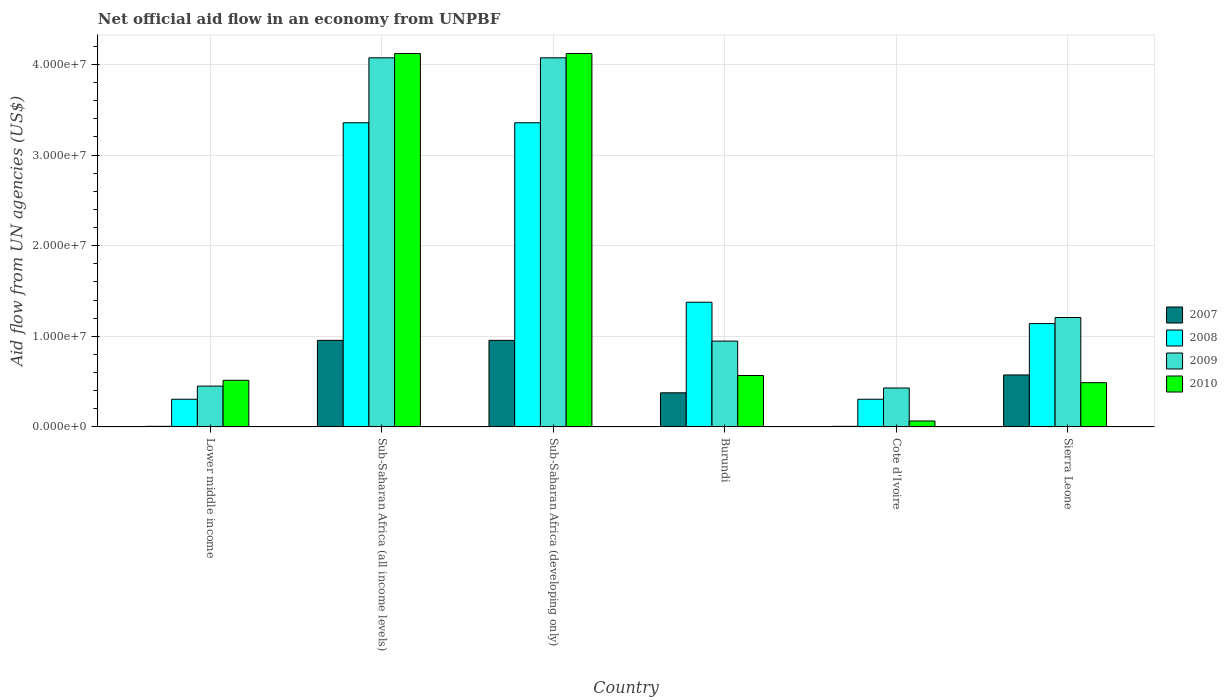Are the number of bars per tick equal to the number of legend labels?
Give a very brief answer. Yes. Are the number of bars on each tick of the X-axis equal?
Your answer should be compact. Yes. How many bars are there on the 3rd tick from the left?
Offer a very short reply. 4. What is the label of the 2nd group of bars from the left?
Give a very brief answer. Sub-Saharan Africa (all income levels). What is the net official aid flow in 2010 in Lower middle income?
Provide a short and direct response. 5.14e+06. Across all countries, what is the maximum net official aid flow in 2010?
Keep it short and to the point. 4.12e+07. Across all countries, what is the minimum net official aid flow in 2009?
Your response must be concise. 4.29e+06. In which country was the net official aid flow in 2009 maximum?
Make the answer very short. Sub-Saharan Africa (all income levels). In which country was the net official aid flow in 2007 minimum?
Keep it short and to the point. Lower middle income. What is the total net official aid flow in 2007 in the graph?
Offer a terse response. 2.87e+07. What is the difference between the net official aid flow in 2010 in Sub-Saharan Africa (all income levels) and that in Sub-Saharan Africa (developing only)?
Provide a succinct answer. 0. What is the difference between the net official aid flow in 2008 in Sierra Leone and the net official aid flow in 2010 in Sub-Saharan Africa (developing only)?
Make the answer very short. -2.98e+07. What is the average net official aid flow in 2009 per country?
Offer a very short reply. 1.86e+07. What is the difference between the net official aid flow of/in 2010 and net official aid flow of/in 2007 in Lower middle income?
Your answer should be very brief. 5.08e+06. What is the ratio of the net official aid flow in 2010 in Burundi to that in Cote d'Ivoire?
Give a very brief answer. 8.72. Is the net official aid flow in 2009 in Lower middle income less than that in Sierra Leone?
Make the answer very short. Yes. What is the difference between the highest and the second highest net official aid flow in 2008?
Provide a succinct answer. 1.98e+07. What is the difference between the highest and the lowest net official aid flow in 2009?
Your response must be concise. 3.64e+07. In how many countries, is the net official aid flow in 2010 greater than the average net official aid flow in 2010 taken over all countries?
Give a very brief answer. 2. Is the sum of the net official aid flow in 2010 in Burundi and Sub-Saharan Africa (developing only) greater than the maximum net official aid flow in 2007 across all countries?
Provide a short and direct response. Yes. Is it the case that in every country, the sum of the net official aid flow in 2008 and net official aid flow in 2010 is greater than the sum of net official aid flow in 2007 and net official aid flow in 2009?
Ensure brevity in your answer.  No. What does the 4th bar from the right in Sierra Leone represents?
Keep it short and to the point. 2007. Is it the case that in every country, the sum of the net official aid flow in 2008 and net official aid flow in 2007 is greater than the net official aid flow in 2010?
Offer a very short reply. No. Are all the bars in the graph horizontal?
Your answer should be compact. No. What is the difference between two consecutive major ticks on the Y-axis?
Make the answer very short. 1.00e+07. Are the values on the major ticks of Y-axis written in scientific E-notation?
Provide a short and direct response. Yes. Does the graph contain any zero values?
Keep it short and to the point. No. Does the graph contain grids?
Your answer should be compact. Yes. How are the legend labels stacked?
Provide a succinct answer. Vertical. What is the title of the graph?
Your answer should be very brief. Net official aid flow in an economy from UNPBF. Does "1999" appear as one of the legend labels in the graph?
Provide a short and direct response. No. What is the label or title of the Y-axis?
Your answer should be very brief. Aid flow from UN agencies (US$). What is the Aid flow from UN agencies (US$) in 2007 in Lower middle income?
Your answer should be compact. 6.00e+04. What is the Aid flow from UN agencies (US$) in 2008 in Lower middle income?
Provide a short and direct response. 3.05e+06. What is the Aid flow from UN agencies (US$) in 2009 in Lower middle income?
Provide a short and direct response. 4.50e+06. What is the Aid flow from UN agencies (US$) in 2010 in Lower middle income?
Your response must be concise. 5.14e+06. What is the Aid flow from UN agencies (US$) of 2007 in Sub-Saharan Africa (all income levels)?
Ensure brevity in your answer.  9.55e+06. What is the Aid flow from UN agencies (US$) of 2008 in Sub-Saharan Africa (all income levels)?
Make the answer very short. 3.36e+07. What is the Aid flow from UN agencies (US$) of 2009 in Sub-Saharan Africa (all income levels)?
Ensure brevity in your answer.  4.07e+07. What is the Aid flow from UN agencies (US$) in 2010 in Sub-Saharan Africa (all income levels)?
Keep it short and to the point. 4.12e+07. What is the Aid flow from UN agencies (US$) of 2007 in Sub-Saharan Africa (developing only)?
Ensure brevity in your answer.  9.55e+06. What is the Aid flow from UN agencies (US$) of 2008 in Sub-Saharan Africa (developing only)?
Your answer should be very brief. 3.36e+07. What is the Aid flow from UN agencies (US$) of 2009 in Sub-Saharan Africa (developing only)?
Your answer should be compact. 4.07e+07. What is the Aid flow from UN agencies (US$) of 2010 in Sub-Saharan Africa (developing only)?
Your response must be concise. 4.12e+07. What is the Aid flow from UN agencies (US$) in 2007 in Burundi?
Make the answer very short. 3.76e+06. What is the Aid flow from UN agencies (US$) in 2008 in Burundi?
Provide a short and direct response. 1.38e+07. What is the Aid flow from UN agencies (US$) of 2009 in Burundi?
Offer a terse response. 9.47e+06. What is the Aid flow from UN agencies (US$) of 2010 in Burundi?
Offer a very short reply. 5.67e+06. What is the Aid flow from UN agencies (US$) in 2008 in Cote d'Ivoire?
Make the answer very short. 3.05e+06. What is the Aid flow from UN agencies (US$) in 2009 in Cote d'Ivoire?
Provide a succinct answer. 4.29e+06. What is the Aid flow from UN agencies (US$) in 2010 in Cote d'Ivoire?
Offer a terse response. 6.50e+05. What is the Aid flow from UN agencies (US$) of 2007 in Sierra Leone?
Ensure brevity in your answer.  5.73e+06. What is the Aid flow from UN agencies (US$) in 2008 in Sierra Leone?
Give a very brief answer. 1.14e+07. What is the Aid flow from UN agencies (US$) in 2009 in Sierra Leone?
Give a very brief answer. 1.21e+07. What is the Aid flow from UN agencies (US$) in 2010 in Sierra Leone?
Ensure brevity in your answer.  4.88e+06. Across all countries, what is the maximum Aid flow from UN agencies (US$) of 2007?
Keep it short and to the point. 9.55e+06. Across all countries, what is the maximum Aid flow from UN agencies (US$) in 2008?
Ensure brevity in your answer.  3.36e+07. Across all countries, what is the maximum Aid flow from UN agencies (US$) of 2009?
Provide a short and direct response. 4.07e+07. Across all countries, what is the maximum Aid flow from UN agencies (US$) in 2010?
Provide a short and direct response. 4.12e+07. Across all countries, what is the minimum Aid flow from UN agencies (US$) of 2008?
Provide a short and direct response. 3.05e+06. Across all countries, what is the minimum Aid flow from UN agencies (US$) in 2009?
Provide a succinct answer. 4.29e+06. Across all countries, what is the minimum Aid flow from UN agencies (US$) of 2010?
Make the answer very short. 6.50e+05. What is the total Aid flow from UN agencies (US$) of 2007 in the graph?
Give a very brief answer. 2.87e+07. What is the total Aid flow from UN agencies (US$) of 2008 in the graph?
Offer a terse response. 9.84e+07. What is the total Aid flow from UN agencies (US$) of 2009 in the graph?
Make the answer very short. 1.12e+08. What is the total Aid flow from UN agencies (US$) of 2010 in the graph?
Offer a very short reply. 9.88e+07. What is the difference between the Aid flow from UN agencies (US$) of 2007 in Lower middle income and that in Sub-Saharan Africa (all income levels)?
Provide a succinct answer. -9.49e+06. What is the difference between the Aid flow from UN agencies (US$) of 2008 in Lower middle income and that in Sub-Saharan Africa (all income levels)?
Offer a very short reply. -3.05e+07. What is the difference between the Aid flow from UN agencies (US$) of 2009 in Lower middle income and that in Sub-Saharan Africa (all income levels)?
Provide a short and direct response. -3.62e+07. What is the difference between the Aid flow from UN agencies (US$) in 2010 in Lower middle income and that in Sub-Saharan Africa (all income levels)?
Offer a terse response. -3.61e+07. What is the difference between the Aid flow from UN agencies (US$) in 2007 in Lower middle income and that in Sub-Saharan Africa (developing only)?
Offer a terse response. -9.49e+06. What is the difference between the Aid flow from UN agencies (US$) of 2008 in Lower middle income and that in Sub-Saharan Africa (developing only)?
Your answer should be compact. -3.05e+07. What is the difference between the Aid flow from UN agencies (US$) of 2009 in Lower middle income and that in Sub-Saharan Africa (developing only)?
Make the answer very short. -3.62e+07. What is the difference between the Aid flow from UN agencies (US$) in 2010 in Lower middle income and that in Sub-Saharan Africa (developing only)?
Your answer should be very brief. -3.61e+07. What is the difference between the Aid flow from UN agencies (US$) in 2007 in Lower middle income and that in Burundi?
Provide a succinct answer. -3.70e+06. What is the difference between the Aid flow from UN agencies (US$) of 2008 in Lower middle income and that in Burundi?
Make the answer very short. -1.07e+07. What is the difference between the Aid flow from UN agencies (US$) in 2009 in Lower middle income and that in Burundi?
Offer a very short reply. -4.97e+06. What is the difference between the Aid flow from UN agencies (US$) of 2010 in Lower middle income and that in Burundi?
Provide a succinct answer. -5.30e+05. What is the difference between the Aid flow from UN agencies (US$) of 2009 in Lower middle income and that in Cote d'Ivoire?
Make the answer very short. 2.10e+05. What is the difference between the Aid flow from UN agencies (US$) in 2010 in Lower middle income and that in Cote d'Ivoire?
Your answer should be compact. 4.49e+06. What is the difference between the Aid flow from UN agencies (US$) of 2007 in Lower middle income and that in Sierra Leone?
Ensure brevity in your answer.  -5.67e+06. What is the difference between the Aid flow from UN agencies (US$) of 2008 in Lower middle income and that in Sierra Leone?
Offer a very short reply. -8.35e+06. What is the difference between the Aid flow from UN agencies (US$) of 2009 in Lower middle income and that in Sierra Leone?
Keep it short and to the point. -7.57e+06. What is the difference between the Aid flow from UN agencies (US$) in 2010 in Lower middle income and that in Sierra Leone?
Your response must be concise. 2.60e+05. What is the difference between the Aid flow from UN agencies (US$) in 2008 in Sub-Saharan Africa (all income levels) and that in Sub-Saharan Africa (developing only)?
Make the answer very short. 0. What is the difference between the Aid flow from UN agencies (US$) of 2010 in Sub-Saharan Africa (all income levels) and that in Sub-Saharan Africa (developing only)?
Your answer should be very brief. 0. What is the difference between the Aid flow from UN agencies (US$) of 2007 in Sub-Saharan Africa (all income levels) and that in Burundi?
Offer a very short reply. 5.79e+06. What is the difference between the Aid flow from UN agencies (US$) of 2008 in Sub-Saharan Africa (all income levels) and that in Burundi?
Your response must be concise. 1.98e+07. What is the difference between the Aid flow from UN agencies (US$) of 2009 in Sub-Saharan Africa (all income levels) and that in Burundi?
Keep it short and to the point. 3.13e+07. What is the difference between the Aid flow from UN agencies (US$) in 2010 in Sub-Saharan Africa (all income levels) and that in Burundi?
Provide a succinct answer. 3.55e+07. What is the difference between the Aid flow from UN agencies (US$) in 2007 in Sub-Saharan Africa (all income levels) and that in Cote d'Ivoire?
Provide a succinct answer. 9.49e+06. What is the difference between the Aid flow from UN agencies (US$) in 2008 in Sub-Saharan Africa (all income levels) and that in Cote d'Ivoire?
Give a very brief answer. 3.05e+07. What is the difference between the Aid flow from UN agencies (US$) in 2009 in Sub-Saharan Africa (all income levels) and that in Cote d'Ivoire?
Ensure brevity in your answer.  3.64e+07. What is the difference between the Aid flow from UN agencies (US$) in 2010 in Sub-Saharan Africa (all income levels) and that in Cote d'Ivoire?
Make the answer very short. 4.06e+07. What is the difference between the Aid flow from UN agencies (US$) in 2007 in Sub-Saharan Africa (all income levels) and that in Sierra Leone?
Offer a terse response. 3.82e+06. What is the difference between the Aid flow from UN agencies (US$) in 2008 in Sub-Saharan Africa (all income levels) and that in Sierra Leone?
Keep it short and to the point. 2.22e+07. What is the difference between the Aid flow from UN agencies (US$) of 2009 in Sub-Saharan Africa (all income levels) and that in Sierra Leone?
Make the answer very short. 2.87e+07. What is the difference between the Aid flow from UN agencies (US$) in 2010 in Sub-Saharan Africa (all income levels) and that in Sierra Leone?
Keep it short and to the point. 3.63e+07. What is the difference between the Aid flow from UN agencies (US$) in 2007 in Sub-Saharan Africa (developing only) and that in Burundi?
Provide a short and direct response. 5.79e+06. What is the difference between the Aid flow from UN agencies (US$) in 2008 in Sub-Saharan Africa (developing only) and that in Burundi?
Offer a terse response. 1.98e+07. What is the difference between the Aid flow from UN agencies (US$) in 2009 in Sub-Saharan Africa (developing only) and that in Burundi?
Keep it short and to the point. 3.13e+07. What is the difference between the Aid flow from UN agencies (US$) in 2010 in Sub-Saharan Africa (developing only) and that in Burundi?
Keep it short and to the point. 3.55e+07. What is the difference between the Aid flow from UN agencies (US$) of 2007 in Sub-Saharan Africa (developing only) and that in Cote d'Ivoire?
Provide a short and direct response. 9.49e+06. What is the difference between the Aid flow from UN agencies (US$) in 2008 in Sub-Saharan Africa (developing only) and that in Cote d'Ivoire?
Provide a succinct answer. 3.05e+07. What is the difference between the Aid flow from UN agencies (US$) of 2009 in Sub-Saharan Africa (developing only) and that in Cote d'Ivoire?
Keep it short and to the point. 3.64e+07. What is the difference between the Aid flow from UN agencies (US$) of 2010 in Sub-Saharan Africa (developing only) and that in Cote d'Ivoire?
Your answer should be very brief. 4.06e+07. What is the difference between the Aid flow from UN agencies (US$) in 2007 in Sub-Saharan Africa (developing only) and that in Sierra Leone?
Provide a short and direct response. 3.82e+06. What is the difference between the Aid flow from UN agencies (US$) in 2008 in Sub-Saharan Africa (developing only) and that in Sierra Leone?
Offer a terse response. 2.22e+07. What is the difference between the Aid flow from UN agencies (US$) of 2009 in Sub-Saharan Africa (developing only) and that in Sierra Leone?
Give a very brief answer. 2.87e+07. What is the difference between the Aid flow from UN agencies (US$) of 2010 in Sub-Saharan Africa (developing only) and that in Sierra Leone?
Make the answer very short. 3.63e+07. What is the difference between the Aid flow from UN agencies (US$) of 2007 in Burundi and that in Cote d'Ivoire?
Keep it short and to the point. 3.70e+06. What is the difference between the Aid flow from UN agencies (US$) of 2008 in Burundi and that in Cote d'Ivoire?
Your response must be concise. 1.07e+07. What is the difference between the Aid flow from UN agencies (US$) of 2009 in Burundi and that in Cote d'Ivoire?
Ensure brevity in your answer.  5.18e+06. What is the difference between the Aid flow from UN agencies (US$) in 2010 in Burundi and that in Cote d'Ivoire?
Make the answer very short. 5.02e+06. What is the difference between the Aid flow from UN agencies (US$) in 2007 in Burundi and that in Sierra Leone?
Provide a succinct answer. -1.97e+06. What is the difference between the Aid flow from UN agencies (US$) of 2008 in Burundi and that in Sierra Leone?
Make the answer very short. 2.36e+06. What is the difference between the Aid flow from UN agencies (US$) in 2009 in Burundi and that in Sierra Leone?
Provide a succinct answer. -2.60e+06. What is the difference between the Aid flow from UN agencies (US$) in 2010 in Burundi and that in Sierra Leone?
Your answer should be compact. 7.90e+05. What is the difference between the Aid flow from UN agencies (US$) of 2007 in Cote d'Ivoire and that in Sierra Leone?
Your answer should be compact. -5.67e+06. What is the difference between the Aid flow from UN agencies (US$) of 2008 in Cote d'Ivoire and that in Sierra Leone?
Give a very brief answer. -8.35e+06. What is the difference between the Aid flow from UN agencies (US$) of 2009 in Cote d'Ivoire and that in Sierra Leone?
Your answer should be compact. -7.78e+06. What is the difference between the Aid flow from UN agencies (US$) in 2010 in Cote d'Ivoire and that in Sierra Leone?
Provide a succinct answer. -4.23e+06. What is the difference between the Aid flow from UN agencies (US$) in 2007 in Lower middle income and the Aid flow from UN agencies (US$) in 2008 in Sub-Saharan Africa (all income levels)?
Give a very brief answer. -3.35e+07. What is the difference between the Aid flow from UN agencies (US$) of 2007 in Lower middle income and the Aid flow from UN agencies (US$) of 2009 in Sub-Saharan Africa (all income levels)?
Make the answer very short. -4.07e+07. What is the difference between the Aid flow from UN agencies (US$) in 2007 in Lower middle income and the Aid flow from UN agencies (US$) in 2010 in Sub-Saharan Africa (all income levels)?
Provide a succinct answer. -4.12e+07. What is the difference between the Aid flow from UN agencies (US$) of 2008 in Lower middle income and the Aid flow from UN agencies (US$) of 2009 in Sub-Saharan Africa (all income levels)?
Give a very brief answer. -3.77e+07. What is the difference between the Aid flow from UN agencies (US$) of 2008 in Lower middle income and the Aid flow from UN agencies (US$) of 2010 in Sub-Saharan Africa (all income levels)?
Ensure brevity in your answer.  -3.82e+07. What is the difference between the Aid flow from UN agencies (US$) of 2009 in Lower middle income and the Aid flow from UN agencies (US$) of 2010 in Sub-Saharan Africa (all income levels)?
Give a very brief answer. -3.67e+07. What is the difference between the Aid flow from UN agencies (US$) of 2007 in Lower middle income and the Aid flow from UN agencies (US$) of 2008 in Sub-Saharan Africa (developing only)?
Make the answer very short. -3.35e+07. What is the difference between the Aid flow from UN agencies (US$) of 2007 in Lower middle income and the Aid flow from UN agencies (US$) of 2009 in Sub-Saharan Africa (developing only)?
Offer a very short reply. -4.07e+07. What is the difference between the Aid flow from UN agencies (US$) of 2007 in Lower middle income and the Aid flow from UN agencies (US$) of 2010 in Sub-Saharan Africa (developing only)?
Your answer should be compact. -4.12e+07. What is the difference between the Aid flow from UN agencies (US$) in 2008 in Lower middle income and the Aid flow from UN agencies (US$) in 2009 in Sub-Saharan Africa (developing only)?
Ensure brevity in your answer.  -3.77e+07. What is the difference between the Aid flow from UN agencies (US$) of 2008 in Lower middle income and the Aid flow from UN agencies (US$) of 2010 in Sub-Saharan Africa (developing only)?
Your answer should be very brief. -3.82e+07. What is the difference between the Aid flow from UN agencies (US$) of 2009 in Lower middle income and the Aid flow from UN agencies (US$) of 2010 in Sub-Saharan Africa (developing only)?
Your answer should be very brief. -3.67e+07. What is the difference between the Aid flow from UN agencies (US$) of 2007 in Lower middle income and the Aid flow from UN agencies (US$) of 2008 in Burundi?
Offer a very short reply. -1.37e+07. What is the difference between the Aid flow from UN agencies (US$) in 2007 in Lower middle income and the Aid flow from UN agencies (US$) in 2009 in Burundi?
Give a very brief answer. -9.41e+06. What is the difference between the Aid flow from UN agencies (US$) of 2007 in Lower middle income and the Aid flow from UN agencies (US$) of 2010 in Burundi?
Offer a terse response. -5.61e+06. What is the difference between the Aid flow from UN agencies (US$) of 2008 in Lower middle income and the Aid flow from UN agencies (US$) of 2009 in Burundi?
Make the answer very short. -6.42e+06. What is the difference between the Aid flow from UN agencies (US$) of 2008 in Lower middle income and the Aid flow from UN agencies (US$) of 2010 in Burundi?
Give a very brief answer. -2.62e+06. What is the difference between the Aid flow from UN agencies (US$) of 2009 in Lower middle income and the Aid flow from UN agencies (US$) of 2010 in Burundi?
Your answer should be compact. -1.17e+06. What is the difference between the Aid flow from UN agencies (US$) in 2007 in Lower middle income and the Aid flow from UN agencies (US$) in 2008 in Cote d'Ivoire?
Provide a succinct answer. -2.99e+06. What is the difference between the Aid flow from UN agencies (US$) of 2007 in Lower middle income and the Aid flow from UN agencies (US$) of 2009 in Cote d'Ivoire?
Make the answer very short. -4.23e+06. What is the difference between the Aid flow from UN agencies (US$) in 2007 in Lower middle income and the Aid flow from UN agencies (US$) in 2010 in Cote d'Ivoire?
Provide a short and direct response. -5.90e+05. What is the difference between the Aid flow from UN agencies (US$) of 2008 in Lower middle income and the Aid flow from UN agencies (US$) of 2009 in Cote d'Ivoire?
Make the answer very short. -1.24e+06. What is the difference between the Aid flow from UN agencies (US$) in 2008 in Lower middle income and the Aid flow from UN agencies (US$) in 2010 in Cote d'Ivoire?
Keep it short and to the point. 2.40e+06. What is the difference between the Aid flow from UN agencies (US$) of 2009 in Lower middle income and the Aid flow from UN agencies (US$) of 2010 in Cote d'Ivoire?
Make the answer very short. 3.85e+06. What is the difference between the Aid flow from UN agencies (US$) in 2007 in Lower middle income and the Aid flow from UN agencies (US$) in 2008 in Sierra Leone?
Your response must be concise. -1.13e+07. What is the difference between the Aid flow from UN agencies (US$) in 2007 in Lower middle income and the Aid flow from UN agencies (US$) in 2009 in Sierra Leone?
Your answer should be compact. -1.20e+07. What is the difference between the Aid flow from UN agencies (US$) in 2007 in Lower middle income and the Aid flow from UN agencies (US$) in 2010 in Sierra Leone?
Give a very brief answer. -4.82e+06. What is the difference between the Aid flow from UN agencies (US$) of 2008 in Lower middle income and the Aid flow from UN agencies (US$) of 2009 in Sierra Leone?
Provide a succinct answer. -9.02e+06. What is the difference between the Aid flow from UN agencies (US$) of 2008 in Lower middle income and the Aid flow from UN agencies (US$) of 2010 in Sierra Leone?
Give a very brief answer. -1.83e+06. What is the difference between the Aid flow from UN agencies (US$) of 2009 in Lower middle income and the Aid flow from UN agencies (US$) of 2010 in Sierra Leone?
Ensure brevity in your answer.  -3.80e+05. What is the difference between the Aid flow from UN agencies (US$) of 2007 in Sub-Saharan Africa (all income levels) and the Aid flow from UN agencies (US$) of 2008 in Sub-Saharan Africa (developing only)?
Make the answer very short. -2.40e+07. What is the difference between the Aid flow from UN agencies (US$) in 2007 in Sub-Saharan Africa (all income levels) and the Aid flow from UN agencies (US$) in 2009 in Sub-Saharan Africa (developing only)?
Offer a terse response. -3.12e+07. What is the difference between the Aid flow from UN agencies (US$) in 2007 in Sub-Saharan Africa (all income levels) and the Aid flow from UN agencies (US$) in 2010 in Sub-Saharan Africa (developing only)?
Your answer should be compact. -3.17e+07. What is the difference between the Aid flow from UN agencies (US$) in 2008 in Sub-Saharan Africa (all income levels) and the Aid flow from UN agencies (US$) in 2009 in Sub-Saharan Africa (developing only)?
Provide a short and direct response. -7.17e+06. What is the difference between the Aid flow from UN agencies (US$) in 2008 in Sub-Saharan Africa (all income levels) and the Aid flow from UN agencies (US$) in 2010 in Sub-Saharan Africa (developing only)?
Offer a terse response. -7.64e+06. What is the difference between the Aid flow from UN agencies (US$) of 2009 in Sub-Saharan Africa (all income levels) and the Aid flow from UN agencies (US$) of 2010 in Sub-Saharan Africa (developing only)?
Offer a very short reply. -4.70e+05. What is the difference between the Aid flow from UN agencies (US$) in 2007 in Sub-Saharan Africa (all income levels) and the Aid flow from UN agencies (US$) in 2008 in Burundi?
Offer a terse response. -4.21e+06. What is the difference between the Aid flow from UN agencies (US$) of 2007 in Sub-Saharan Africa (all income levels) and the Aid flow from UN agencies (US$) of 2010 in Burundi?
Offer a very short reply. 3.88e+06. What is the difference between the Aid flow from UN agencies (US$) of 2008 in Sub-Saharan Africa (all income levels) and the Aid flow from UN agencies (US$) of 2009 in Burundi?
Keep it short and to the point. 2.41e+07. What is the difference between the Aid flow from UN agencies (US$) in 2008 in Sub-Saharan Africa (all income levels) and the Aid flow from UN agencies (US$) in 2010 in Burundi?
Your answer should be compact. 2.79e+07. What is the difference between the Aid flow from UN agencies (US$) in 2009 in Sub-Saharan Africa (all income levels) and the Aid flow from UN agencies (US$) in 2010 in Burundi?
Your answer should be compact. 3.51e+07. What is the difference between the Aid flow from UN agencies (US$) in 2007 in Sub-Saharan Africa (all income levels) and the Aid flow from UN agencies (US$) in 2008 in Cote d'Ivoire?
Your answer should be very brief. 6.50e+06. What is the difference between the Aid flow from UN agencies (US$) in 2007 in Sub-Saharan Africa (all income levels) and the Aid flow from UN agencies (US$) in 2009 in Cote d'Ivoire?
Your response must be concise. 5.26e+06. What is the difference between the Aid flow from UN agencies (US$) in 2007 in Sub-Saharan Africa (all income levels) and the Aid flow from UN agencies (US$) in 2010 in Cote d'Ivoire?
Give a very brief answer. 8.90e+06. What is the difference between the Aid flow from UN agencies (US$) in 2008 in Sub-Saharan Africa (all income levels) and the Aid flow from UN agencies (US$) in 2009 in Cote d'Ivoire?
Ensure brevity in your answer.  2.93e+07. What is the difference between the Aid flow from UN agencies (US$) of 2008 in Sub-Saharan Africa (all income levels) and the Aid flow from UN agencies (US$) of 2010 in Cote d'Ivoire?
Offer a terse response. 3.29e+07. What is the difference between the Aid flow from UN agencies (US$) in 2009 in Sub-Saharan Africa (all income levels) and the Aid flow from UN agencies (US$) in 2010 in Cote d'Ivoire?
Make the answer very short. 4.01e+07. What is the difference between the Aid flow from UN agencies (US$) in 2007 in Sub-Saharan Africa (all income levels) and the Aid flow from UN agencies (US$) in 2008 in Sierra Leone?
Your response must be concise. -1.85e+06. What is the difference between the Aid flow from UN agencies (US$) in 2007 in Sub-Saharan Africa (all income levels) and the Aid flow from UN agencies (US$) in 2009 in Sierra Leone?
Your response must be concise. -2.52e+06. What is the difference between the Aid flow from UN agencies (US$) in 2007 in Sub-Saharan Africa (all income levels) and the Aid flow from UN agencies (US$) in 2010 in Sierra Leone?
Offer a terse response. 4.67e+06. What is the difference between the Aid flow from UN agencies (US$) of 2008 in Sub-Saharan Africa (all income levels) and the Aid flow from UN agencies (US$) of 2009 in Sierra Leone?
Provide a short and direct response. 2.15e+07. What is the difference between the Aid flow from UN agencies (US$) in 2008 in Sub-Saharan Africa (all income levels) and the Aid flow from UN agencies (US$) in 2010 in Sierra Leone?
Your response must be concise. 2.87e+07. What is the difference between the Aid flow from UN agencies (US$) of 2009 in Sub-Saharan Africa (all income levels) and the Aid flow from UN agencies (US$) of 2010 in Sierra Leone?
Provide a succinct answer. 3.59e+07. What is the difference between the Aid flow from UN agencies (US$) of 2007 in Sub-Saharan Africa (developing only) and the Aid flow from UN agencies (US$) of 2008 in Burundi?
Provide a short and direct response. -4.21e+06. What is the difference between the Aid flow from UN agencies (US$) in 2007 in Sub-Saharan Africa (developing only) and the Aid flow from UN agencies (US$) in 2010 in Burundi?
Offer a very short reply. 3.88e+06. What is the difference between the Aid flow from UN agencies (US$) in 2008 in Sub-Saharan Africa (developing only) and the Aid flow from UN agencies (US$) in 2009 in Burundi?
Offer a terse response. 2.41e+07. What is the difference between the Aid flow from UN agencies (US$) in 2008 in Sub-Saharan Africa (developing only) and the Aid flow from UN agencies (US$) in 2010 in Burundi?
Keep it short and to the point. 2.79e+07. What is the difference between the Aid flow from UN agencies (US$) of 2009 in Sub-Saharan Africa (developing only) and the Aid flow from UN agencies (US$) of 2010 in Burundi?
Ensure brevity in your answer.  3.51e+07. What is the difference between the Aid flow from UN agencies (US$) of 2007 in Sub-Saharan Africa (developing only) and the Aid flow from UN agencies (US$) of 2008 in Cote d'Ivoire?
Make the answer very short. 6.50e+06. What is the difference between the Aid flow from UN agencies (US$) of 2007 in Sub-Saharan Africa (developing only) and the Aid flow from UN agencies (US$) of 2009 in Cote d'Ivoire?
Keep it short and to the point. 5.26e+06. What is the difference between the Aid flow from UN agencies (US$) of 2007 in Sub-Saharan Africa (developing only) and the Aid flow from UN agencies (US$) of 2010 in Cote d'Ivoire?
Your answer should be compact. 8.90e+06. What is the difference between the Aid flow from UN agencies (US$) of 2008 in Sub-Saharan Africa (developing only) and the Aid flow from UN agencies (US$) of 2009 in Cote d'Ivoire?
Your answer should be compact. 2.93e+07. What is the difference between the Aid flow from UN agencies (US$) in 2008 in Sub-Saharan Africa (developing only) and the Aid flow from UN agencies (US$) in 2010 in Cote d'Ivoire?
Offer a very short reply. 3.29e+07. What is the difference between the Aid flow from UN agencies (US$) in 2009 in Sub-Saharan Africa (developing only) and the Aid flow from UN agencies (US$) in 2010 in Cote d'Ivoire?
Provide a succinct answer. 4.01e+07. What is the difference between the Aid flow from UN agencies (US$) in 2007 in Sub-Saharan Africa (developing only) and the Aid flow from UN agencies (US$) in 2008 in Sierra Leone?
Your answer should be compact. -1.85e+06. What is the difference between the Aid flow from UN agencies (US$) in 2007 in Sub-Saharan Africa (developing only) and the Aid flow from UN agencies (US$) in 2009 in Sierra Leone?
Offer a very short reply. -2.52e+06. What is the difference between the Aid flow from UN agencies (US$) in 2007 in Sub-Saharan Africa (developing only) and the Aid flow from UN agencies (US$) in 2010 in Sierra Leone?
Your response must be concise. 4.67e+06. What is the difference between the Aid flow from UN agencies (US$) of 2008 in Sub-Saharan Africa (developing only) and the Aid flow from UN agencies (US$) of 2009 in Sierra Leone?
Keep it short and to the point. 2.15e+07. What is the difference between the Aid flow from UN agencies (US$) in 2008 in Sub-Saharan Africa (developing only) and the Aid flow from UN agencies (US$) in 2010 in Sierra Leone?
Keep it short and to the point. 2.87e+07. What is the difference between the Aid flow from UN agencies (US$) of 2009 in Sub-Saharan Africa (developing only) and the Aid flow from UN agencies (US$) of 2010 in Sierra Leone?
Keep it short and to the point. 3.59e+07. What is the difference between the Aid flow from UN agencies (US$) in 2007 in Burundi and the Aid flow from UN agencies (US$) in 2008 in Cote d'Ivoire?
Give a very brief answer. 7.10e+05. What is the difference between the Aid flow from UN agencies (US$) in 2007 in Burundi and the Aid flow from UN agencies (US$) in 2009 in Cote d'Ivoire?
Provide a short and direct response. -5.30e+05. What is the difference between the Aid flow from UN agencies (US$) of 2007 in Burundi and the Aid flow from UN agencies (US$) of 2010 in Cote d'Ivoire?
Your response must be concise. 3.11e+06. What is the difference between the Aid flow from UN agencies (US$) of 2008 in Burundi and the Aid flow from UN agencies (US$) of 2009 in Cote d'Ivoire?
Offer a very short reply. 9.47e+06. What is the difference between the Aid flow from UN agencies (US$) of 2008 in Burundi and the Aid flow from UN agencies (US$) of 2010 in Cote d'Ivoire?
Keep it short and to the point. 1.31e+07. What is the difference between the Aid flow from UN agencies (US$) in 2009 in Burundi and the Aid flow from UN agencies (US$) in 2010 in Cote d'Ivoire?
Your response must be concise. 8.82e+06. What is the difference between the Aid flow from UN agencies (US$) in 2007 in Burundi and the Aid flow from UN agencies (US$) in 2008 in Sierra Leone?
Offer a very short reply. -7.64e+06. What is the difference between the Aid flow from UN agencies (US$) of 2007 in Burundi and the Aid flow from UN agencies (US$) of 2009 in Sierra Leone?
Provide a succinct answer. -8.31e+06. What is the difference between the Aid flow from UN agencies (US$) of 2007 in Burundi and the Aid flow from UN agencies (US$) of 2010 in Sierra Leone?
Keep it short and to the point. -1.12e+06. What is the difference between the Aid flow from UN agencies (US$) in 2008 in Burundi and the Aid flow from UN agencies (US$) in 2009 in Sierra Leone?
Provide a succinct answer. 1.69e+06. What is the difference between the Aid flow from UN agencies (US$) of 2008 in Burundi and the Aid flow from UN agencies (US$) of 2010 in Sierra Leone?
Give a very brief answer. 8.88e+06. What is the difference between the Aid flow from UN agencies (US$) in 2009 in Burundi and the Aid flow from UN agencies (US$) in 2010 in Sierra Leone?
Your answer should be compact. 4.59e+06. What is the difference between the Aid flow from UN agencies (US$) in 2007 in Cote d'Ivoire and the Aid flow from UN agencies (US$) in 2008 in Sierra Leone?
Ensure brevity in your answer.  -1.13e+07. What is the difference between the Aid flow from UN agencies (US$) of 2007 in Cote d'Ivoire and the Aid flow from UN agencies (US$) of 2009 in Sierra Leone?
Offer a very short reply. -1.20e+07. What is the difference between the Aid flow from UN agencies (US$) in 2007 in Cote d'Ivoire and the Aid flow from UN agencies (US$) in 2010 in Sierra Leone?
Provide a short and direct response. -4.82e+06. What is the difference between the Aid flow from UN agencies (US$) of 2008 in Cote d'Ivoire and the Aid flow from UN agencies (US$) of 2009 in Sierra Leone?
Give a very brief answer. -9.02e+06. What is the difference between the Aid flow from UN agencies (US$) in 2008 in Cote d'Ivoire and the Aid flow from UN agencies (US$) in 2010 in Sierra Leone?
Keep it short and to the point. -1.83e+06. What is the difference between the Aid flow from UN agencies (US$) in 2009 in Cote d'Ivoire and the Aid flow from UN agencies (US$) in 2010 in Sierra Leone?
Offer a very short reply. -5.90e+05. What is the average Aid flow from UN agencies (US$) in 2007 per country?
Your answer should be compact. 4.78e+06. What is the average Aid flow from UN agencies (US$) in 2008 per country?
Provide a short and direct response. 1.64e+07. What is the average Aid flow from UN agencies (US$) of 2009 per country?
Your answer should be very brief. 1.86e+07. What is the average Aid flow from UN agencies (US$) in 2010 per country?
Your response must be concise. 1.65e+07. What is the difference between the Aid flow from UN agencies (US$) in 2007 and Aid flow from UN agencies (US$) in 2008 in Lower middle income?
Offer a terse response. -2.99e+06. What is the difference between the Aid flow from UN agencies (US$) in 2007 and Aid flow from UN agencies (US$) in 2009 in Lower middle income?
Your answer should be very brief. -4.44e+06. What is the difference between the Aid flow from UN agencies (US$) of 2007 and Aid flow from UN agencies (US$) of 2010 in Lower middle income?
Give a very brief answer. -5.08e+06. What is the difference between the Aid flow from UN agencies (US$) in 2008 and Aid flow from UN agencies (US$) in 2009 in Lower middle income?
Your response must be concise. -1.45e+06. What is the difference between the Aid flow from UN agencies (US$) of 2008 and Aid flow from UN agencies (US$) of 2010 in Lower middle income?
Keep it short and to the point. -2.09e+06. What is the difference between the Aid flow from UN agencies (US$) in 2009 and Aid flow from UN agencies (US$) in 2010 in Lower middle income?
Your answer should be very brief. -6.40e+05. What is the difference between the Aid flow from UN agencies (US$) of 2007 and Aid flow from UN agencies (US$) of 2008 in Sub-Saharan Africa (all income levels)?
Provide a short and direct response. -2.40e+07. What is the difference between the Aid flow from UN agencies (US$) of 2007 and Aid flow from UN agencies (US$) of 2009 in Sub-Saharan Africa (all income levels)?
Provide a short and direct response. -3.12e+07. What is the difference between the Aid flow from UN agencies (US$) in 2007 and Aid flow from UN agencies (US$) in 2010 in Sub-Saharan Africa (all income levels)?
Provide a succinct answer. -3.17e+07. What is the difference between the Aid flow from UN agencies (US$) in 2008 and Aid flow from UN agencies (US$) in 2009 in Sub-Saharan Africa (all income levels)?
Offer a very short reply. -7.17e+06. What is the difference between the Aid flow from UN agencies (US$) of 2008 and Aid flow from UN agencies (US$) of 2010 in Sub-Saharan Africa (all income levels)?
Make the answer very short. -7.64e+06. What is the difference between the Aid flow from UN agencies (US$) of 2009 and Aid flow from UN agencies (US$) of 2010 in Sub-Saharan Africa (all income levels)?
Offer a terse response. -4.70e+05. What is the difference between the Aid flow from UN agencies (US$) of 2007 and Aid flow from UN agencies (US$) of 2008 in Sub-Saharan Africa (developing only)?
Ensure brevity in your answer.  -2.40e+07. What is the difference between the Aid flow from UN agencies (US$) of 2007 and Aid flow from UN agencies (US$) of 2009 in Sub-Saharan Africa (developing only)?
Provide a short and direct response. -3.12e+07. What is the difference between the Aid flow from UN agencies (US$) of 2007 and Aid flow from UN agencies (US$) of 2010 in Sub-Saharan Africa (developing only)?
Offer a terse response. -3.17e+07. What is the difference between the Aid flow from UN agencies (US$) of 2008 and Aid flow from UN agencies (US$) of 2009 in Sub-Saharan Africa (developing only)?
Ensure brevity in your answer.  -7.17e+06. What is the difference between the Aid flow from UN agencies (US$) of 2008 and Aid flow from UN agencies (US$) of 2010 in Sub-Saharan Africa (developing only)?
Ensure brevity in your answer.  -7.64e+06. What is the difference between the Aid flow from UN agencies (US$) of 2009 and Aid flow from UN agencies (US$) of 2010 in Sub-Saharan Africa (developing only)?
Your answer should be very brief. -4.70e+05. What is the difference between the Aid flow from UN agencies (US$) in 2007 and Aid flow from UN agencies (US$) in 2008 in Burundi?
Provide a succinct answer. -1.00e+07. What is the difference between the Aid flow from UN agencies (US$) of 2007 and Aid flow from UN agencies (US$) of 2009 in Burundi?
Give a very brief answer. -5.71e+06. What is the difference between the Aid flow from UN agencies (US$) in 2007 and Aid flow from UN agencies (US$) in 2010 in Burundi?
Give a very brief answer. -1.91e+06. What is the difference between the Aid flow from UN agencies (US$) in 2008 and Aid flow from UN agencies (US$) in 2009 in Burundi?
Your answer should be compact. 4.29e+06. What is the difference between the Aid flow from UN agencies (US$) in 2008 and Aid flow from UN agencies (US$) in 2010 in Burundi?
Keep it short and to the point. 8.09e+06. What is the difference between the Aid flow from UN agencies (US$) of 2009 and Aid flow from UN agencies (US$) of 2010 in Burundi?
Ensure brevity in your answer.  3.80e+06. What is the difference between the Aid flow from UN agencies (US$) of 2007 and Aid flow from UN agencies (US$) of 2008 in Cote d'Ivoire?
Offer a very short reply. -2.99e+06. What is the difference between the Aid flow from UN agencies (US$) of 2007 and Aid flow from UN agencies (US$) of 2009 in Cote d'Ivoire?
Keep it short and to the point. -4.23e+06. What is the difference between the Aid flow from UN agencies (US$) in 2007 and Aid flow from UN agencies (US$) in 2010 in Cote d'Ivoire?
Your answer should be compact. -5.90e+05. What is the difference between the Aid flow from UN agencies (US$) in 2008 and Aid flow from UN agencies (US$) in 2009 in Cote d'Ivoire?
Keep it short and to the point. -1.24e+06. What is the difference between the Aid flow from UN agencies (US$) in 2008 and Aid flow from UN agencies (US$) in 2010 in Cote d'Ivoire?
Your response must be concise. 2.40e+06. What is the difference between the Aid flow from UN agencies (US$) of 2009 and Aid flow from UN agencies (US$) of 2010 in Cote d'Ivoire?
Ensure brevity in your answer.  3.64e+06. What is the difference between the Aid flow from UN agencies (US$) of 2007 and Aid flow from UN agencies (US$) of 2008 in Sierra Leone?
Your answer should be compact. -5.67e+06. What is the difference between the Aid flow from UN agencies (US$) in 2007 and Aid flow from UN agencies (US$) in 2009 in Sierra Leone?
Offer a very short reply. -6.34e+06. What is the difference between the Aid flow from UN agencies (US$) in 2007 and Aid flow from UN agencies (US$) in 2010 in Sierra Leone?
Provide a succinct answer. 8.50e+05. What is the difference between the Aid flow from UN agencies (US$) of 2008 and Aid flow from UN agencies (US$) of 2009 in Sierra Leone?
Give a very brief answer. -6.70e+05. What is the difference between the Aid flow from UN agencies (US$) of 2008 and Aid flow from UN agencies (US$) of 2010 in Sierra Leone?
Give a very brief answer. 6.52e+06. What is the difference between the Aid flow from UN agencies (US$) of 2009 and Aid flow from UN agencies (US$) of 2010 in Sierra Leone?
Your answer should be very brief. 7.19e+06. What is the ratio of the Aid flow from UN agencies (US$) in 2007 in Lower middle income to that in Sub-Saharan Africa (all income levels)?
Keep it short and to the point. 0.01. What is the ratio of the Aid flow from UN agencies (US$) of 2008 in Lower middle income to that in Sub-Saharan Africa (all income levels)?
Provide a short and direct response. 0.09. What is the ratio of the Aid flow from UN agencies (US$) of 2009 in Lower middle income to that in Sub-Saharan Africa (all income levels)?
Keep it short and to the point. 0.11. What is the ratio of the Aid flow from UN agencies (US$) of 2010 in Lower middle income to that in Sub-Saharan Africa (all income levels)?
Provide a succinct answer. 0.12. What is the ratio of the Aid flow from UN agencies (US$) in 2007 in Lower middle income to that in Sub-Saharan Africa (developing only)?
Provide a succinct answer. 0.01. What is the ratio of the Aid flow from UN agencies (US$) in 2008 in Lower middle income to that in Sub-Saharan Africa (developing only)?
Your answer should be compact. 0.09. What is the ratio of the Aid flow from UN agencies (US$) in 2009 in Lower middle income to that in Sub-Saharan Africa (developing only)?
Give a very brief answer. 0.11. What is the ratio of the Aid flow from UN agencies (US$) in 2010 in Lower middle income to that in Sub-Saharan Africa (developing only)?
Your answer should be compact. 0.12. What is the ratio of the Aid flow from UN agencies (US$) of 2007 in Lower middle income to that in Burundi?
Make the answer very short. 0.02. What is the ratio of the Aid flow from UN agencies (US$) in 2008 in Lower middle income to that in Burundi?
Your answer should be compact. 0.22. What is the ratio of the Aid flow from UN agencies (US$) of 2009 in Lower middle income to that in Burundi?
Your answer should be compact. 0.48. What is the ratio of the Aid flow from UN agencies (US$) of 2010 in Lower middle income to that in Burundi?
Offer a terse response. 0.91. What is the ratio of the Aid flow from UN agencies (US$) of 2009 in Lower middle income to that in Cote d'Ivoire?
Your answer should be very brief. 1.05. What is the ratio of the Aid flow from UN agencies (US$) in 2010 in Lower middle income to that in Cote d'Ivoire?
Keep it short and to the point. 7.91. What is the ratio of the Aid flow from UN agencies (US$) in 2007 in Lower middle income to that in Sierra Leone?
Provide a short and direct response. 0.01. What is the ratio of the Aid flow from UN agencies (US$) in 2008 in Lower middle income to that in Sierra Leone?
Provide a short and direct response. 0.27. What is the ratio of the Aid flow from UN agencies (US$) of 2009 in Lower middle income to that in Sierra Leone?
Provide a short and direct response. 0.37. What is the ratio of the Aid flow from UN agencies (US$) in 2010 in Lower middle income to that in Sierra Leone?
Provide a succinct answer. 1.05. What is the ratio of the Aid flow from UN agencies (US$) of 2008 in Sub-Saharan Africa (all income levels) to that in Sub-Saharan Africa (developing only)?
Keep it short and to the point. 1. What is the ratio of the Aid flow from UN agencies (US$) in 2010 in Sub-Saharan Africa (all income levels) to that in Sub-Saharan Africa (developing only)?
Offer a very short reply. 1. What is the ratio of the Aid flow from UN agencies (US$) of 2007 in Sub-Saharan Africa (all income levels) to that in Burundi?
Your answer should be compact. 2.54. What is the ratio of the Aid flow from UN agencies (US$) of 2008 in Sub-Saharan Africa (all income levels) to that in Burundi?
Your response must be concise. 2.44. What is the ratio of the Aid flow from UN agencies (US$) of 2009 in Sub-Saharan Africa (all income levels) to that in Burundi?
Make the answer very short. 4.3. What is the ratio of the Aid flow from UN agencies (US$) of 2010 in Sub-Saharan Africa (all income levels) to that in Burundi?
Your answer should be very brief. 7.27. What is the ratio of the Aid flow from UN agencies (US$) of 2007 in Sub-Saharan Africa (all income levels) to that in Cote d'Ivoire?
Provide a short and direct response. 159.17. What is the ratio of the Aid flow from UN agencies (US$) of 2008 in Sub-Saharan Africa (all income levels) to that in Cote d'Ivoire?
Give a very brief answer. 11.01. What is the ratio of the Aid flow from UN agencies (US$) of 2009 in Sub-Saharan Africa (all income levels) to that in Cote d'Ivoire?
Offer a very short reply. 9.5. What is the ratio of the Aid flow from UN agencies (US$) in 2010 in Sub-Saharan Africa (all income levels) to that in Cote d'Ivoire?
Make the answer very short. 63.4. What is the ratio of the Aid flow from UN agencies (US$) in 2008 in Sub-Saharan Africa (all income levels) to that in Sierra Leone?
Offer a terse response. 2.94. What is the ratio of the Aid flow from UN agencies (US$) in 2009 in Sub-Saharan Africa (all income levels) to that in Sierra Leone?
Your answer should be very brief. 3.38. What is the ratio of the Aid flow from UN agencies (US$) in 2010 in Sub-Saharan Africa (all income levels) to that in Sierra Leone?
Give a very brief answer. 8.44. What is the ratio of the Aid flow from UN agencies (US$) in 2007 in Sub-Saharan Africa (developing only) to that in Burundi?
Your answer should be compact. 2.54. What is the ratio of the Aid flow from UN agencies (US$) of 2008 in Sub-Saharan Africa (developing only) to that in Burundi?
Provide a short and direct response. 2.44. What is the ratio of the Aid flow from UN agencies (US$) of 2009 in Sub-Saharan Africa (developing only) to that in Burundi?
Provide a short and direct response. 4.3. What is the ratio of the Aid flow from UN agencies (US$) in 2010 in Sub-Saharan Africa (developing only) to that in Burundi?
Ensure brevity in your answer.  7.27. What is the ratio of the Aid flow from UN agencies (US$) of 2007 in Sub-Saharan Africa (developing only) to that in Cote d'Ivoire?
Ensure brevity in your answer.  159.17. What is the ratio of the Aid flow from UN agencies (US$) of 2008 in Sub-Saharan Africa (developing only) to that in Cote d'Ivoire?
Make the answer very short. 11.01. What is the ratio of the Aid flow from UN agencies (US$) of 2009 in Sub-Saharan Africa (developing only) to that in Cote d'Ivoire?
Your answer should be very brief. 9.5. What is the ratio of the Aid flow from UN agencies (US$) in 2010 in Sub-Saharan Africa (developing only) to that in Cote d'Ivoire?
Give a very brief answer. 63.4. What is the ratio of the Aid flow from UN agencies (US$) in 2008 in Sub-Saharan Africa (developing only) to that in Sierra Leone?
Your response must be concise. 2.94. What is the ratio of the Aid flow from UN agencies (US$) of 2009 in Sub-Saharan Africa (developing only) to that in Sierra Leone?
Make the answer very short. 3.38. What is the ratio of the Aid flow from UN agencies (US$) of 2010 in Sub-Saharan Africa (developing only) to that in Sierra Leone?
Your answer should be compact. 8.44. What is the ratio of the Aid flow from UN agencies (US$) in 2007 in Burundi to that in Cote d'Ivoire?
Ensure brevity in your answer.  62.67. What is the ratio of the Aid flow from UN agencies (US$) of 2008 in Burundi to that in Cote d'Ivoire?
Offer a terse response. 4.51. What is the ratio of the Aid flow from UN agencies (US$) in 2009 in Burundi to that in Cote d'Ivoire?
Provide a succinct answer. 2.21. What is the ratio of the Aid flow from UN agencies (US$) in 2010 in Burundi to that in Cote d'Ivoire?
Ensure brevity in your answer.  8.72. What is the ratio of the Aid flow from UN agencies (US$) of 2007 in Burundi to that in Sierra Leone?
Your answer should be compact. 0.66. What is the ratio of the Aid flow from UN agencies (US$) in 2008 in Burundi to that in Sierra Leone?
Your response must be concise. 1.21. What is the ratio of the Aid flow from UN agencies (US$) of 2009 in Burundi to that in Sierra Leone?
Give a very brief answer. 0.78. What is the ratio of the Aid flow from UN agencies (US$) in 2010 in Burundi to that in Sierra Leone?
Give a very brief answer. 1.16. What is the ratio of the Aid flow from UN agencies (US$) in 2007 in Cote d'Ivoire to that in Sierra Leone?
Keep it short and to the point. 0.01. What is the ratio of the Aid flow from UN agencies (US$) of 2008 in Cote d'Ivoire to that in Sierra Leone?
Provide a succinct answer. 0.27. What is the ratio of the Aid flow from UN agencies (US$) in 2009 in Cote d'Ivoire to that in Sierra Leone?
Provide a short and direct response. 0.36. What is the ratio of the Aid flow from UN agencies (US$) of 2010 in Cote d'Ivoire to that in Sierra Leone?
Give a very brief answer. 0.13. What is the difference between the highest and the second highest Aid flow from UN agencies (US$) in 2008?
Your answer should be compact. 0. What is the difference between the highest and the second highest Aid flow from UN agencies (US$) of 2010?
Provide a short and direct response. 0. What is the difference between the highest and the lowest Aid flow from UN agencies (US$) of 2007?
Offer a very short reply. 9.49e+06. What is the difference between the highest and the lowest Aid flow from UN agencies (US$) in 2008?
Keep it short and to the point. 3.05e+07. What is the difference between the highest and the lowest Aid flow from UN agencies (US$) in 2009?
Make the answer very short. 3.64e+07. What is the difference between the highest and the lowest Aid flow from UN agencies (US$) in 2010?
Give a very brief answer. 4.06e+07. 